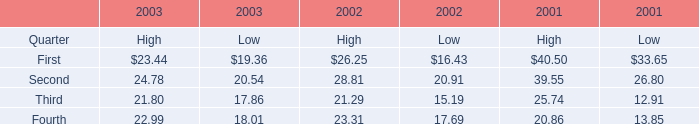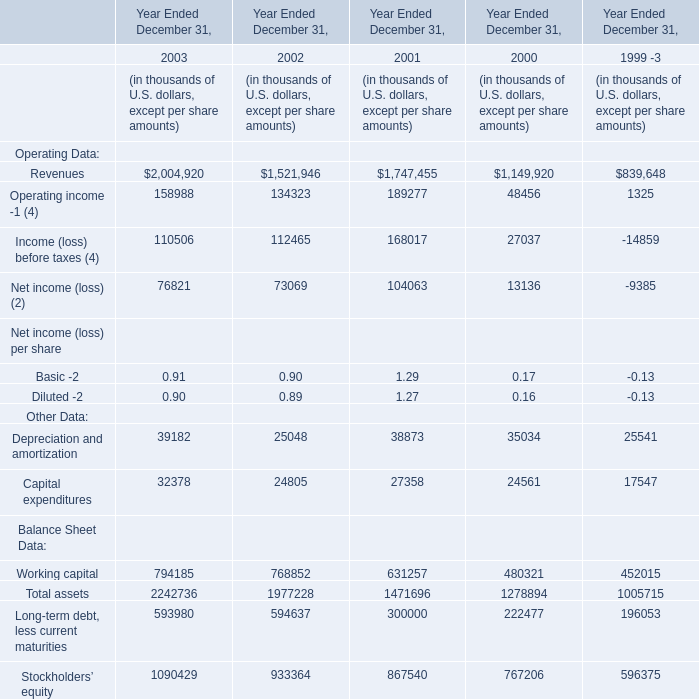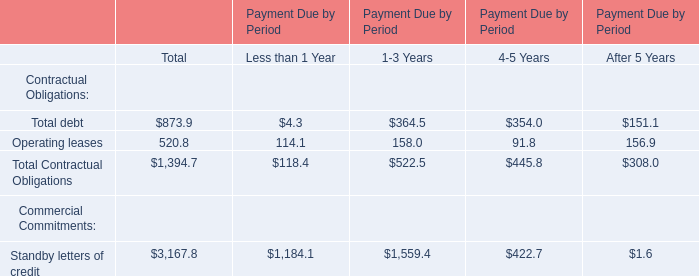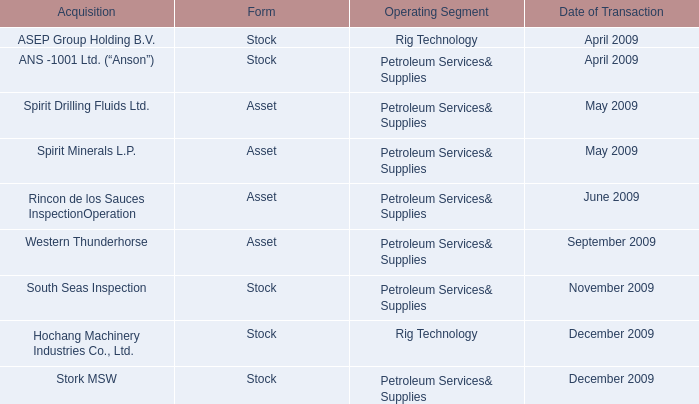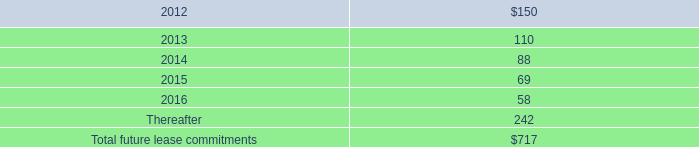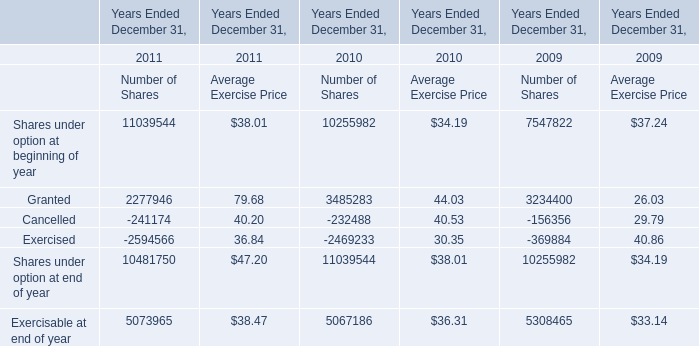what was the difference in millions of cash payments for federal , state , and foreign income taxes between 2013 and 2014? 
Computations: (189.5 - 90.7)
Answer: 98.8. 